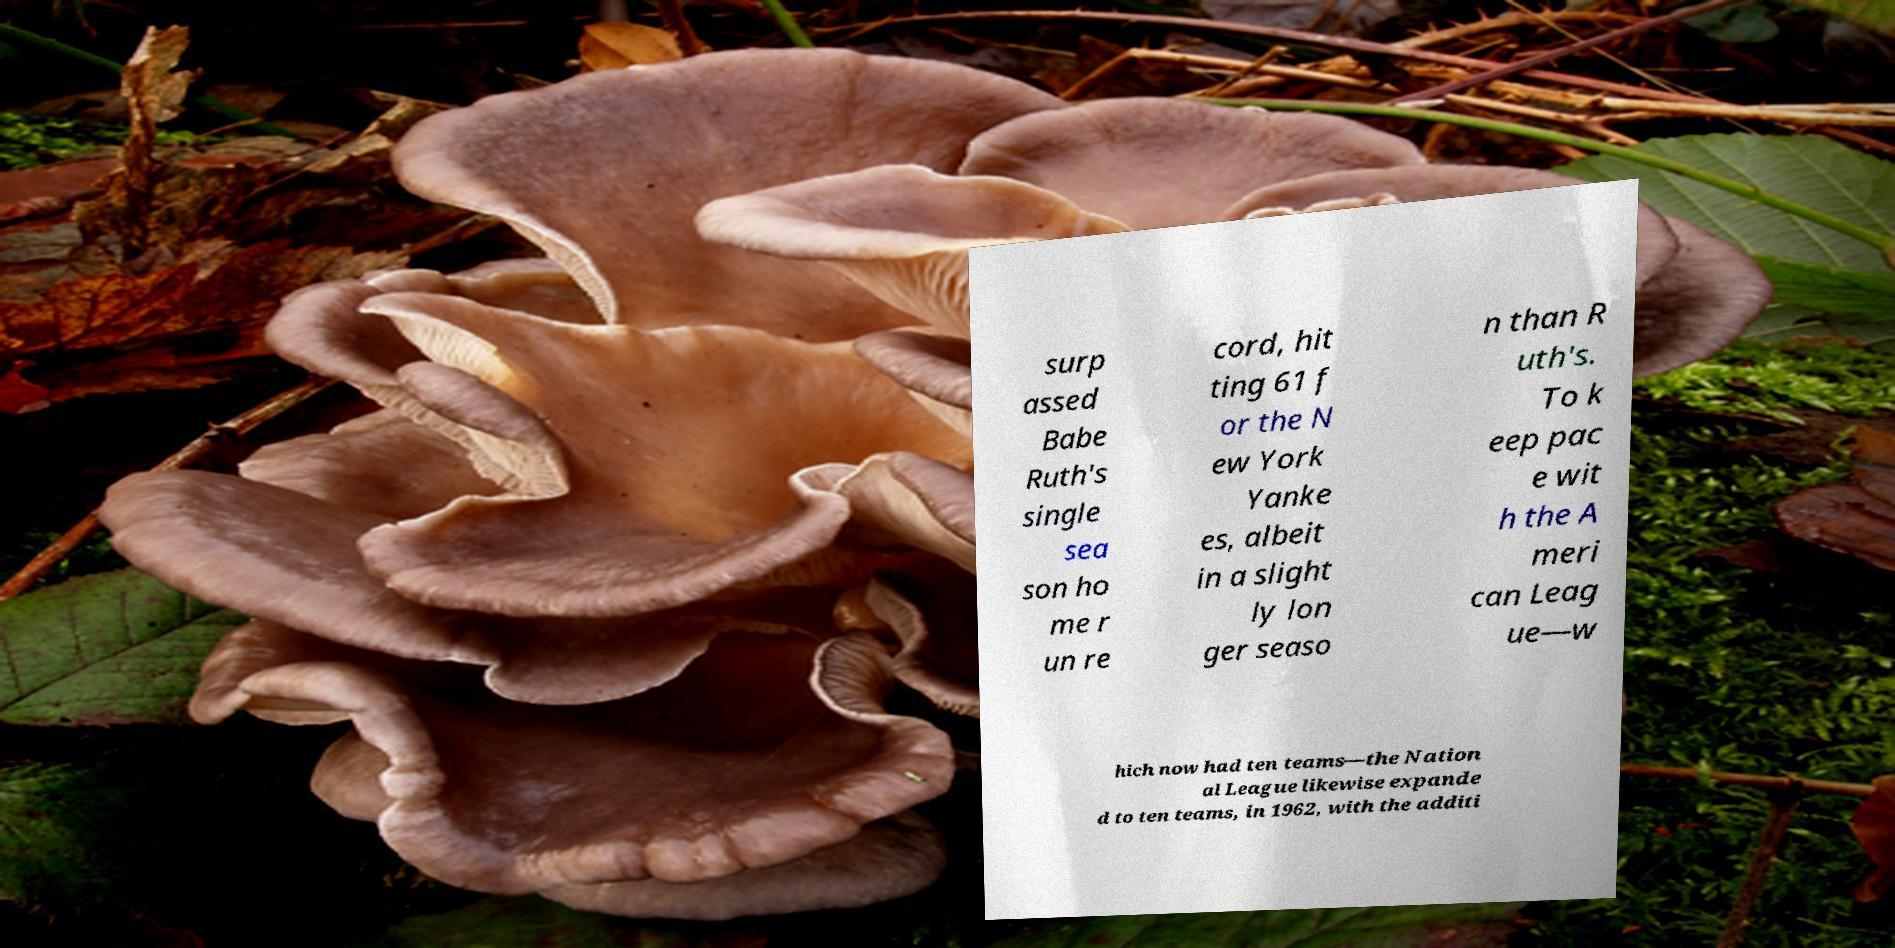Can you read and provide the text displayed in the image?This photo seems to have some interesting text. Can you extract and type it out for me? surp assed Babe Ruth's single sea son ho me r un re cord, hit ting 61 f or the N ew York Yanke es, albeit in a slight ly lon ger seaso n than R uth's. To k eep pac e wit h the A meri can Leag ue—w hich now had ten teams—the Nation al League likewise expande d to ten teams, in 1962, with the additi 